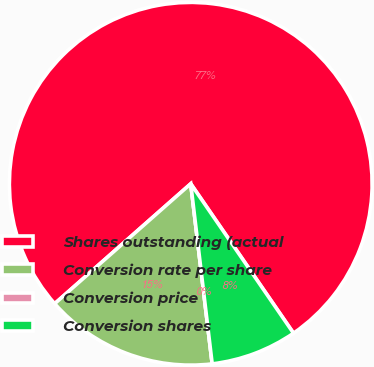Convert chart. <chart><loc_0><loc_0><loc_500><loc_500><pie_chart><fcel>Shares outstanding (actual<fcel>Conversion rate per share<fcel>Conversion price<fcel>Conversion shares<nl><fcel>76.91%<fcel>15.39%<fcel>0.0%<fcel>7.7%<nl></chart> 